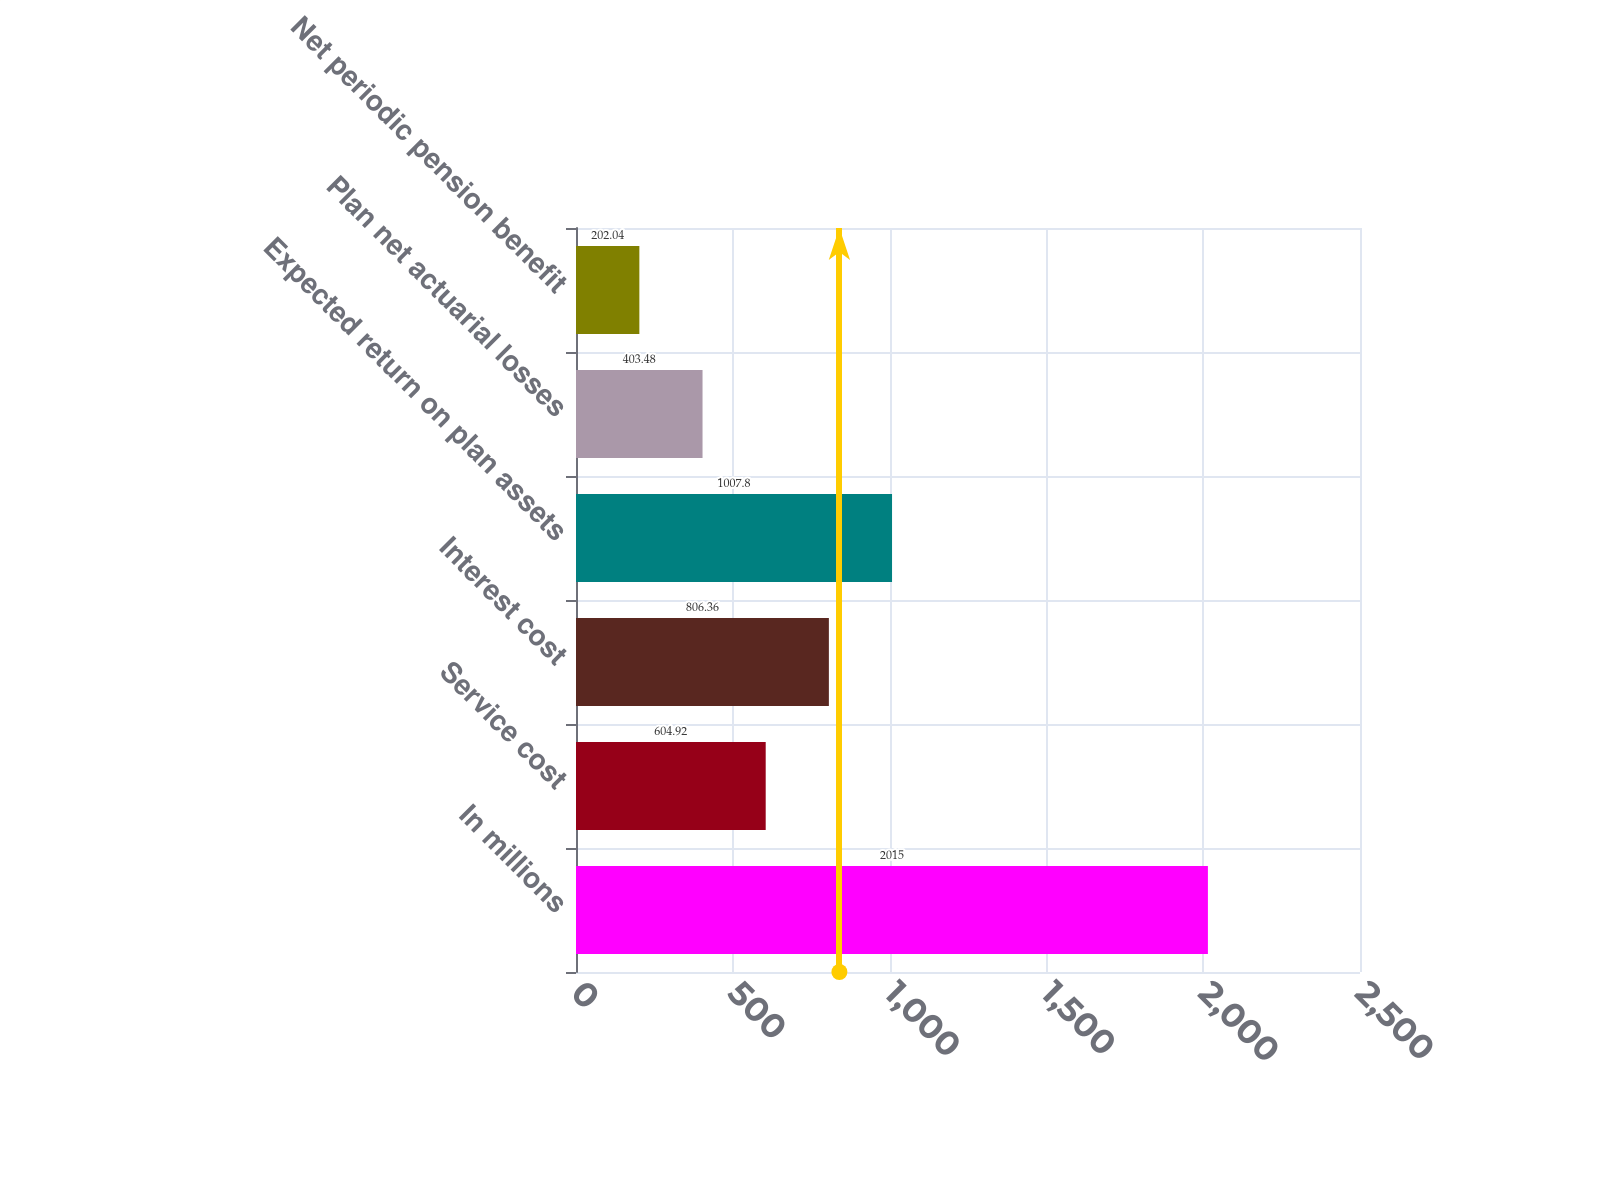Convert chart. <chart><loc_0><loc_0><loc_500><loc_500><bar_chart><fcel>In millions<fcel>Service cost<fcel>Interest cost<fcel>Expected return on plan assets<fcel>Plan net actuarial losses<fcel>Net periodic pension benefit<nl><fcel>2015<fcel>604.92<fcel>806.36<fcel>1007.8<fcel>403.48<fcel>202.04<nl></chart> 